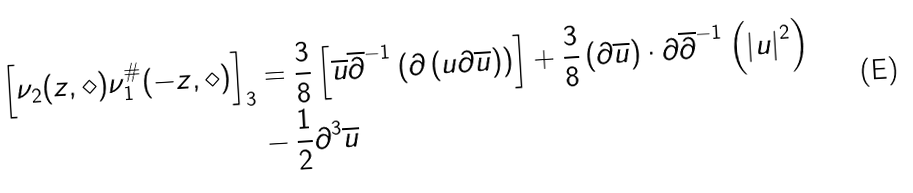<formula> <loc_0><loc_0><loc_500><loc_500>\left [ \nu _ { 2 } ( z , \diamond ) \nu _ { 1 } ^ { \# } ( - z , \diamond ) \right ] _ { 3 } & = \frac { 3 } { 8 } \left [ \overline { u } \overline { \partial } ^ { - 1 } \left ( \partial \left ( u \partial \overline { u } \right ) \right ) \right ] + \frac { 3 } { 8 } \left ( \partial \overline { u } \right ) \cdot \partial \overline { \partial } ^ { - 1 } \left ( \left | u \right | ^ { 2 } \right ) \\ & - \frac { 1 } { 2 } \partial ^ { 3 } \overline { u }</formula> 